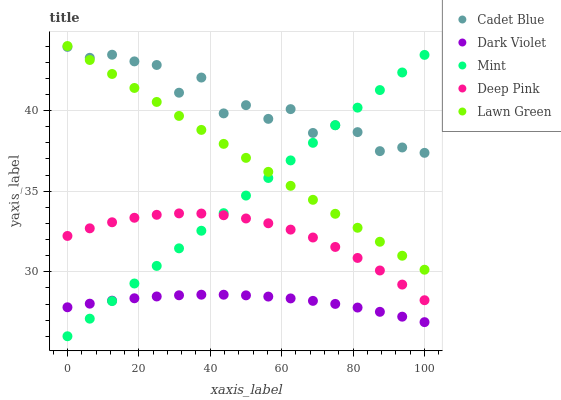Does Dark Violet have the minimum area under the curve?
Answer yes or no. Yes. Does Cadet Blue have the maximum area under the curve?
Answer yes or no. Yes. Does Mint have the minimum area under the curve?
Answer yes or no. No. Does Mint have the maximum area under the curve?
Answer yes or no. No. Is Mint the smoothest?
Answer yes or no. Yes. Is Cadet Blue the roughest?
Answer yes or no. Yes. Is Cadet Blue the smoothest?
Answer yes or no. No. Is Mint the roughest?
Answer yes or no. No. Does Mint have the lowest value?
Answer yes or no. Yes. Does Cadet Blue have the lowest value?
Answer yes or no. No. Does Lawn Green have the highest value?
Answer yes or no. Yes. Does Cadet Blue have the highest value?
Answer yes or no. No. Is Dark Violet less than Lawn Green?
Answer yes or no. Yes. Is Deep Pink greater than Dark Violet?
Answer yes or no. Yes. Does Dark Violet intersect Mint?
Answer yes or no. Yes. Is Dark Violet less than Mint?
Answer yes or no. No. Is Dark Violet greater than Mint?
Answer yes or no. No. Does Dark Violet intersect Lawn Green?
Answer yes or no. No. 